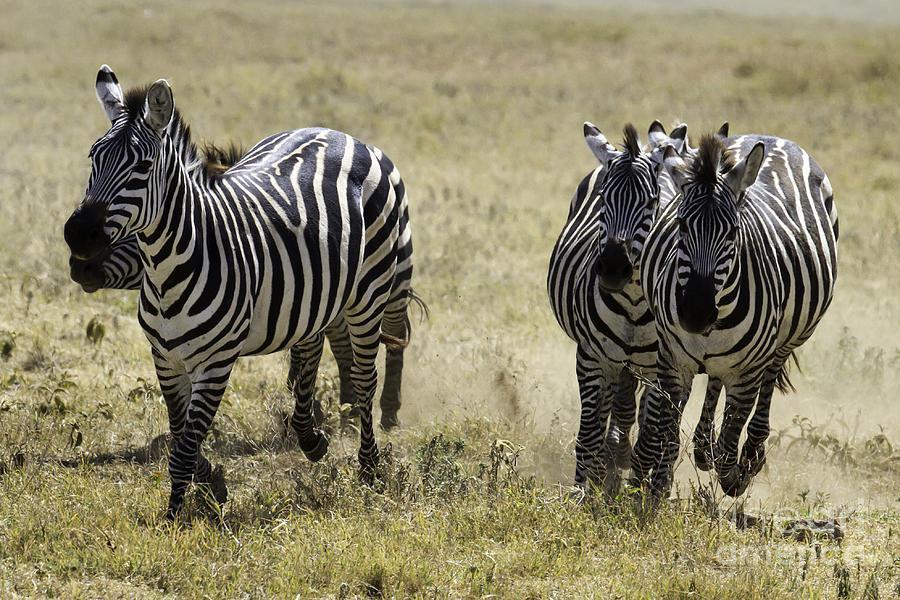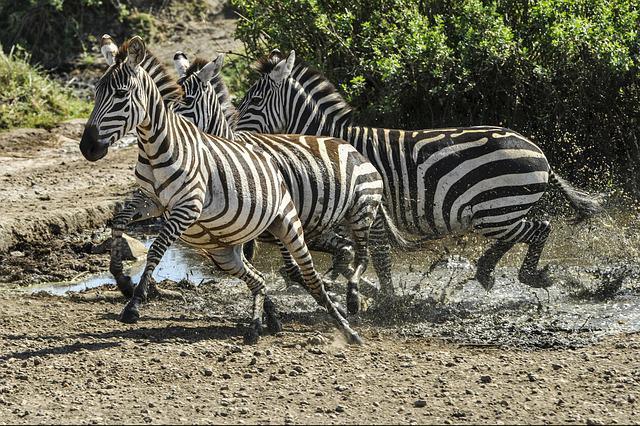The first image is the image on the left, the second image is the image on the right. Analyze the images presented: Is the assertion "One image shows at least four zebras running forward, and the other image shows at least two zebras running leftward." valid? Answer yes or no. Yes. 